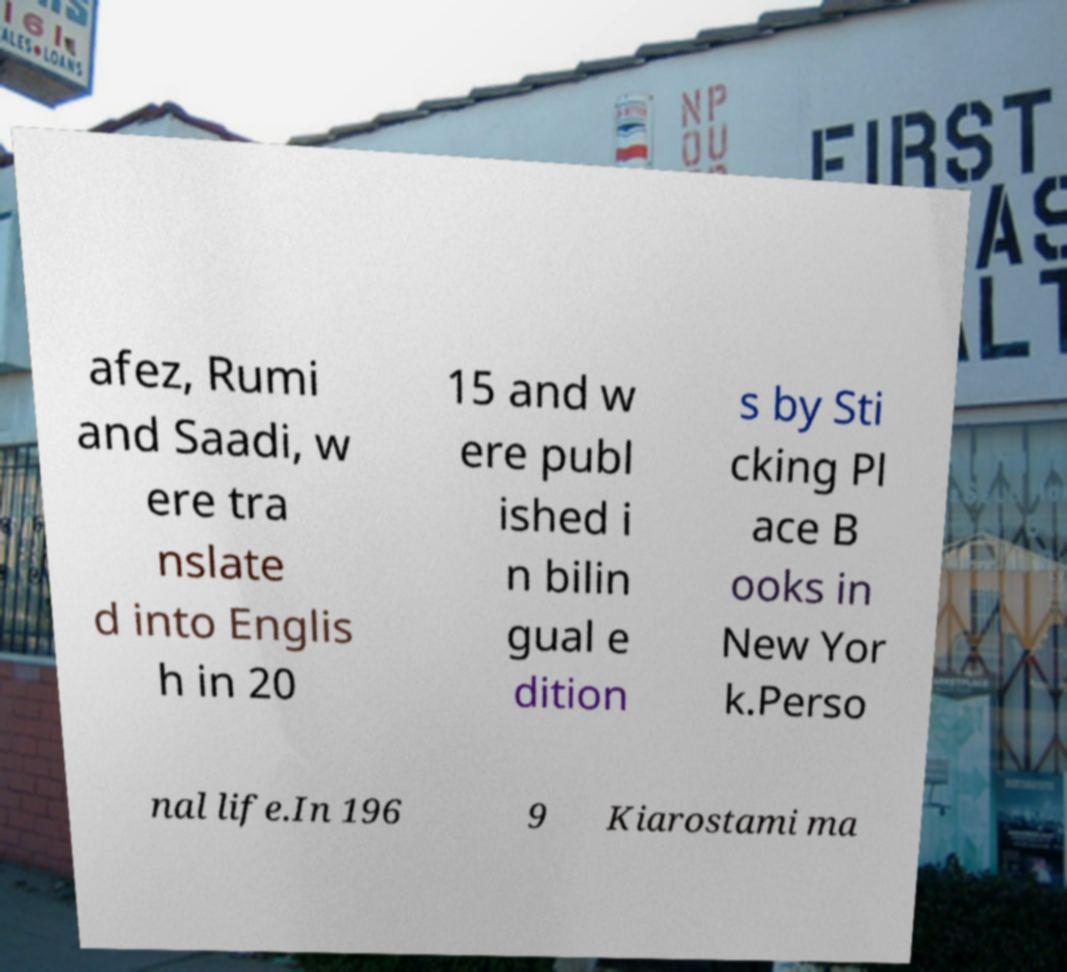There's text embedded in this image that I need extracted. Can you transcribe it verbatim? afez, Rumi and Saadi, w ere tra nslate d into Englis h in 20 15 and w ere publ ished i n bilin gual e dition s by Sti cking Pl ace B ooks in New Yor k.Perso nal life.In 196 9 Kiarostami ma 